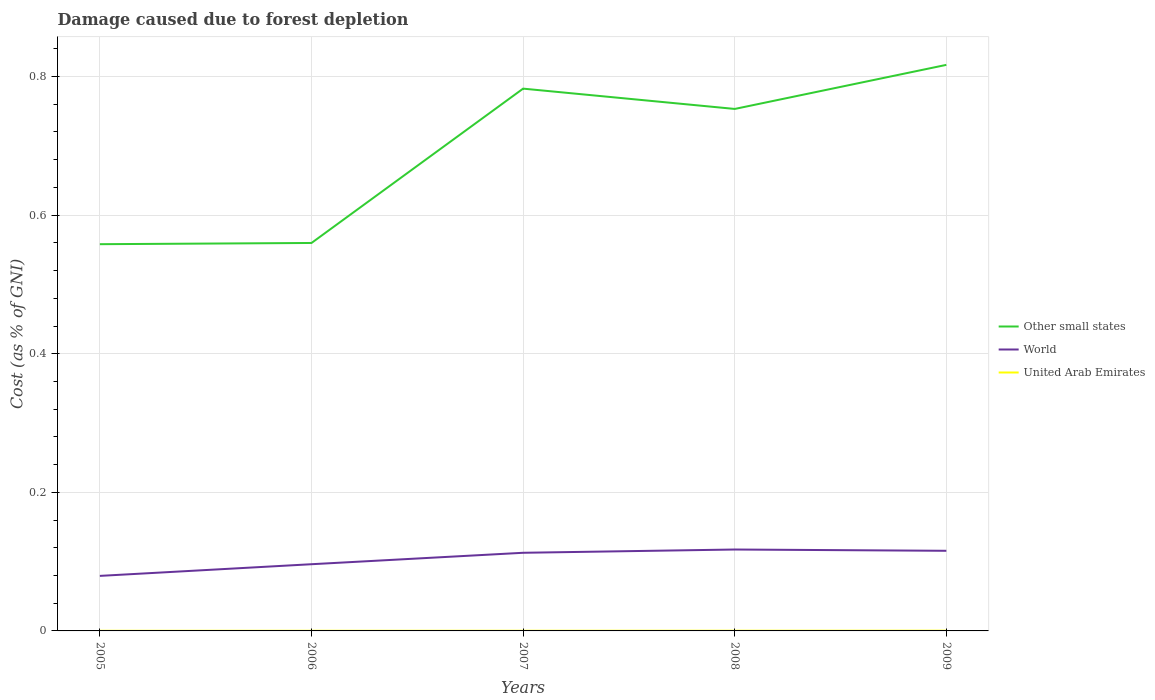How many different coloured lines are there?
Your answer should be compact. 3. Is the number of lines equal to the number of legend labels?
Offer a very short reply. Yes. Across all years, what is the maximum cost of damage caused due to forest depletion in Other small states?
Your answer should be very brief. 0.56. In which year was the cost of damage caused due to forest depletion in World maximum?
Give a very brief answer. 2005. What is the total cost of damage caused due to forest depletion in World in the graph?
Make the answer very short. -0.02. What is the difference between the highest and the second highest cost of damage caused due to forest depletion in World?
Provide a short and direct response. 0.04. What is the difference between the highest and the lowest cost of damage caused due to forest depletion in United Arab Emirates?
Your answer should be very brief. 2. How many years are there in the graph?
Offer a terse response. 5. What is the difference between two consecutive major ticks on the Y-axis?
Make the answer very short. 0.2. Are the values on the major ticks of Y-axis written in scientific E-notation?
Provide a short and direct response. No. Does the graph contain any zero values?
Your response must be concise. No. How are the legend labels stacked?
Ensure brevity in your answer.  Vertical. What is the title of the graph?
Keep it short and to the point. Damage caused due to forest depletion. What is the label or title of the Y-axis?
Provide a succinct answer. Cost (as % of GNI). What is the Cost (as % of GNI) in Other small states in 2005?
Your answer should be compact. 0.56. What is the Cost (as % of GNI) of World in 2005?
Your answer should be compact. 0.08. What is the Cost (as % of GNI) in United Arab Emirates in 2005?
Your answer should be compact. 0. What is the Cost (as % of GNI) in Other small states in 2006?
Your answer should be very brief. 0.56. What is the Cost (as % of GNI) in World in 2006?
Provide a succinct answer. 0.1. What is the Cost (as % of GNI) in United Arab Emirates in 2006?
Make the answer very short. 0. What is the Cost (as % of GNI) in Other small states in 2007?
Your answer should be compact. 0.78. What is the Cost (as % of GNI) in World in 2007?
Provide a short and direct response. 0.11. What is the Cost (as % of GNI) in United Arab Emirates in 2007?
Make the answer very short. 0. What is the Cost (as % of GNI) in Other small states in 2008?
Offer a very short reply. 0.75. What is the Cost (as % of GNI) of World in 2008?
Keep it short and to the point. 0.12. What is the Cost (as % of GNI) in United Arab Emirates in 2008?
Provide a short and direct response. 0. What is the Cost (as % of GNI) in Other small states in 2009?
Your response must be concise. 0.82. What is the Cost (as % of GNI) in World in 2009?
Your answer should be compact. 0.12. What is the Cost (as % of GNI) in United Arab Emirates in 2009?
Make the answer very short. 0. Across all years, what is the maximum Cost (as % of GNI) in Other small states?
Make the answer very short. 0.82. Across all years, what is the maximum Cost (as % of GNI) of World?
Keep it short and to the point. 0.12. Across all years, what is the maximum Cost (as % of GNI) in United Arab Emirates?
Give a very brief answer. 0. Across all years, what is the minimum Cost (as % of GNI) in Other small states?
Your answer should be compact. 0.56. Across all years, what is the minimum Cost (as % of GNI) of World?
Your answer should be very brief. 0.08. Across all years, what is the minimum Cost (as % of GNI) of United Arab Emirates?
Ensure brevity in your answer.  0. What is the total Cost (as % of GNI) of Other small states in the graph?
Ensure brevity in your answer.  3.47. What is the total Cost (as % of GNI) in World in the graph?
Make the answer very short. 0.52. What is the total Cost (as % of GNI) in United Arab Emirates in the graph?
Your answer should be compact. 0. What is the difference between the Cost (as % of GNI) in Other small states in 2005 and that in 2006?
Your response must be concise. -0. What is the difference between the Cost (as % of GNI) of World in 2005 and that in 2006?
Offer a terse response. -0.02. What is the difference between the Cost (as % of GNI) in Other small states in 2005 and that in 2007?
Your response must be concise. -0.22. What is the difference between the Cost (as % of GNI) in World in 2005 and that in 2007?
Offer a terse response. -0.03. What is the difference between the Cost (as % of GNI) in Other small states in 2005 and that in 2008?
Your answer should be compact. -0.2. What is the difference between the Cost (as % of GNI) of World in 2005 and that in 2008?
Make the answer very short. -0.04. What is the difference between the Cost (as % of GNI) in United Arab Emirates in 2005 and that in 2008?
Provide a short and direct response. -0. What is the difference between the Cost (as % of GNI) in Other small states in 2005 and that in 2009?
Your answer should be compact. -0.26. What is the difference between the Cost (as % of GNI) in World in 2005 and that in 2009?
Your response must be concise. -0.04. What is the difference between the Cost (as % of GNI) of United Arab Emirates in 2005 and that in 2009?
Your answer should be compact. -0. What is the difference between the Cost (as % of GNI) in Other small states in 2006 and that in 2007?
Ensure brevity in your answer.  -0.22. What is the difference between the Cost (as % of GNI) in World in 2006 and that in 2007?
Your answer should be very brief. -0.02. What is the difference between the Cost (as % of GNI) of Other small states in 2006 and that in 2008?
Provide a succinct answer. -0.19. What is the difference between the Cost (as % of GNI) in World in 2006 and that in 2008?
Your answer should be compact. -0.02. What is the difference between the Cost (as % of GNI) of United Arab Emirates in 2006 and that in 2008?
Ensure brevity in your answer.  -0. What is the difference between the Cost (as % of GNI) of Other small states in 2006 and that in 2009?
Give a very brief answer. -0.26. What is the difference between the Cost (as % of GNI) in World in 2006 and that in 2009?
Your response must be concise. -0.02. What is the difference between the Cost (as % of GNI) of United Arab Emirates in 2006 and that in 2009?
Your answer should be very brief. -0. What is the difference between the Cost (as % of GNI) of Other small states in 2007 and that in 2008?
Ensure brevity in your answer.  0.03. What is the difference between the Cost (as % of GNI) of World in 2007 and that in 2008?
Offer a very short reply. -0. What is the difference between the Cost (as % of GNI) of United Arab Emirates in 2007 and that in 2008?
Your response must be concise. -0. What is the difference between the Cost (as % of GNI) in Other small states in 2007 and that in 2009?
Offer a terse response. -0.03. What is the difference between the Cost (as % of GNI) in World in 2007 and that in 2009?
Offer a very short reply. -0. What is the difference between the Cost (as % of GNI) in United Arab Emirates in 2007 and that in 2009?
Provide a short and direct response. -0. What is the difference between the Cost (as % of GNI) in Other small states in 2008 and that in 2009?
Offer a very short reply. -0.06. What is the difference between the Cost (as % of GNI) of World in 2008 and that in 2009?
Offer a very short reply. 0. What is the difference between the Cost (as % of GNI) of United Arab Emirates in 2008 and that in 2009?
Provide a short and direct response. -0. What is the difference between the Cost (as % of GNI) in Other small states in 2005 and the Cost (as % of GNI) in World in 2006?
Make the answer very short. 0.46. What is the difference between the Cost (as % of GNI) of Other small states in 2005 and the Cost (as % of GNI) of United Arab Emirates in 2006?
Provide a short and direct response. 0.56. What is the difference between the Cost (as % of GNI) in World in 2005 and the Cost (as % of GNI) in United Arab Emirates in 2006?
Make the answer very short. 0.08. What is the difference between the Cost (as % of GNI) in Other small states in 2005 and the Cost (as % of GNI) in World in 2007?
Provide a short and direct response. 0.45. What is the difference between the Cost (as % of GNI) in Other small states in 2005 and the Cost (as % of GNI) in United Arab Emirates in 2007?
Keep it short and to the point. 0.56. What is the difference between the Cost (as % of GNI) of World in 2005 and the Cost (as % of GNI) of United Arab Emirates in 2007?
Offer a very short reply. 0.08. What is the difference between the Cost (as % of GNI) in Other small states in 2005 and the Cost (as % of GNI) in World in 2008?
Ensure brevity in your answer.  0.44. What is the difference between the Cost (as % of GNI) in Other small states in 2005 and the Cost (as % of GNI) in United Arab Emirates in 2008?
Offer a very short reply. 0.56. What is the difference between the Cost (as % of GNI) of World in 2005 and the Cost (as % of GNI) of United Arab Emirates in 2008?
Your answer should be very brief. 0.08. What is the difference between the Cost (as % of GNI) in Other small states in 2005 and the Cost (as % of GNI) in World in 2009?
Offer a very short reply. 0.44. What is the difference between the Cost (as % of GNI) of Other small states in 2005 and the Cost (as % of GNI) of United Arab Emirates in 2009?
Offer a terse response. 0.56. What is the difference between the Cost (as % of GNI) in World in 2005 and the Cost (as % of GNI) in United Arab Emirates in 2009?
Offer a very short reply. 0.08. What is the difference between the Cost (as % of GNI) in Other small states in 2006 and the Cost (as % of GNI) in World in 2007?
Your answer should be compact. 0.45. What is the difference between the Cost (as % of GNI) in Other small states in 2006 and the Cost (as % of GNI) in United Arab Emirates in 2007?
Your answer should be very brief. 0.56. What is the difference between the Cost (as % of GNI) of World in 2006 and the Cost (as % of GNI) of United Arab Emirates in 2007?
Offer a terse response. 0.1. What is the difference between the Cost (as % of GNI) of Other small states in 2006 and the Cost (as % of GNI) of World in 2008?
Ensure brevity in your answer.  0.44. What is the difference between the Cost (as % of GNI) of Other small states in 2006 and the Cost (as % of GNI) of United Arab Emirates in 2008?
Your answer should be compact. 0.56. What is the difference between the Cost (as % of GNI) in World in 2006 and the Cost (as % of GNI) in United Arab Emirates in 2008?
Offer a terse response. 0.1. What is the difference between the Cost (as % of GNI) of Other small states in 2006 and the Cost (as % of GNI) of World in 2009?
Give a very brief answer. 0.44. What is the difference between the Cost (as % of GNI) in Other small states in 2006 and the Cost (as % of GNI) in United Arab Emirates in 2009?
Ensure brevity in your answer.  0.56. What is the difference between the Cost (as % of GNI) of World in 2006 and the Cost (as % of GNI) of United Arab Emirates in 2009?
Keep it short and to the point. 0.1. What is the difference between the Cost (as % of GNI) of Other small states in 2007 and the Cost (as % of GNI) of World in 2008?
Ensure brevity in your answer.  0.67. What is the difference between the Cost (as % of GNI) in Other small states in 2007 and the Cost (as % of GNI) in United Arab Emirates in 2008?
Make the answer very short. 0.78. What is the difference between the Cost (as % of GNI) of World in 2007 and the Cost (as % of GNI) of United Arab Emirates in 2008?
Your answer should be very brief. 0.11. What is the difference between the Cost (as % of GNI) in Other small states in 2007 and the Cost (as % of GNI) in World in 2009?
Offer a very short reply. 0.67. What is the difference between the Cost (as % of GNI) of Other small states in 2007 and the Cost (as % of GNI) of United Arab Emirates in 2009?
Offer a very short reply. 0.78. What is the difference between the Cost (as % of GNI) of World in 2007 and the Cost (as % of GNI) of United Arab Emirates in 2009?
Give a very brief answer. 0.11. What is the difference between the Cost (as % of GNI) in Other small states in 2008 and the Cost (as % of GNI) in World in 2009?
Give a very brief answer. 0.64. What is the difference between the Cost (as % of GNI) of Other small states in 2008 and the Cost (as % of GNI) of United Arab Emirates in 2009?
Provide a short and direct response. 0.75. What is the difference between the Cost (as % of GNI) in World in 2008 and the Cost (as % of GNI) in United Arab Emirates in 2009?
Your answer should be compact. 0.12. What is the average Cost (as % of GNI) in Other small states per year?
Your answer should be very brief. 0.69. What is the average Cost (as % of GNI) of World per year?
Your response must be concise. 0.1. In the year 2005, what is the difference between the Cost (as % of GNI) in Other small states and Cost (as % of GNI) in World?
Give a very brief answer. 0.48. In the year 2005, what is the difference between the Cost (as % of GNI) of Other small states and Cost (as % of GNI) of United Arab Emirates?
Provide a short and direct response. 0.56. In the year 2005, what is the difference between the Cost (as % of GNI) in World and Cost (as % of GNI) in United Arab Emirates?
Give a very brief answer. 0.08. In the year 2006, what is the difference between the Cost (as % of GNI) of Other small states and Cost (as % of GNI) of World?
Offer a terse response. 0.46. In the year 2006, what is the difference between the Cost (as % of GNI) of Other small states and Cost (as % of GNI) of United Arab Emirates?
Ensure brevity in your answer.  0.56. In the year 2006, what is the difference between the Cost (as % of GNI) in World and Cost (as % of GNI) in United Arab Emirates?
Offer a terse response. 0.1. In the year 2007, what is the difference between the Cost (as % of GNI) in Other small states and Cost (as % of GNI) in World?
Your answer should be very brief. 0.67. In the year 2007, what is the difference between the Cost (as % of GNI) in Other small states and Cost (as % of GNI) in United Arab Emirates?
Give a very brief answer. 0.78. In the year 2007, what is the difference between the Cost (as % of GNI) of World and Cost (as % of GNI) of United Arab Emirates?
Your answer should be very brief. 0.11. In the year 2008, what is the difference between the Cost (as % of GNI) of Other small states and Cost (as % of GNI) of World?
Make the answer very short. 0.64. In the year 2008, what is the difference between the Cost (as % of GNI) in Other small states and Cost (as % of GNI) in United Arab Emirates?
Your answer should be very brief. 0.75. In the year 2008, what is the difference between the Cost (as % of GNI) in World and Cost (as % of GNI) in United Arab Emirates?
Ensure brevity in your answer.  0.12. In the year 2009, what is the difference between the Cost (as % of GNI) of Other small states and Cost (as % of GNI) of World?
Your response must be concise. 0.7. In the year 2009, what is the difference between the Cost (as % of GNI) of Other small states and Cost (as % of GNI) of United Arab Emirates?
Offer a terse response. 0.82. In the year 2009, what is the difference between the Cost (as % of GNI) of World and Cost (as % of GNI) of United Arab Emirates?
Offer a terse response. 0.12. What is the ratio of the Cost (as % of GNI) in World in 2005 to that in 2006?
Offer a terse response. 0.83. What is the ratio of the Cost (as % of GNI) in United Arab Emirates in 2005 to that in 2006?
Your response must be concise. 0.96. What is the ratio of the Cost (as % of GNI) in Other small states in 2005 to that in 2007?
Offer a terse response. 0.71. What is the ratio of the Cost (as % of GNI) in World in 2005 to that in 2007?
Your answer should be compact. 0.7. What is the ratio of the Cost (as % of GNI) of United Arab Emirates in 2005 to that in 2007?
Your answer should be compact. 0.81. What is the ratio of the Cost (as % of GNI) in Other small states in 2005 to that in 2008?
Ensure brevity in your answer.  0.74. What is the ratio of the Cost (as % of GNI) in World in 2005 to that in 2008?
Make the answer very short. 0.68. What is the ratio of the Cost (as % of GNI) in United Arab Emirates in 2005 to that in 2008?
Your answer should be very brief. 0.7. What is the ratio of the Cost (as % of GNI) in Other small states in 2005 to that in 2009?
Keep it short and to the point. 0.68. What is the ratio of the Cost (as % of GNI) of World in 2005 to that in 2009?
Your answer should be compact. 0.69. What is the ratio of the Cost (as % of GNI) of United Arab Emirates in 2005 to that in 2009?
Provide a short and direct response. 0.59. What is the ratio of the Cost (as % of GNI) of Other small states in 2006 to that in 2007?
Your answer should be very brief. 0.72. What is the ratio of the Cost (as % of GNI) of World in 2006 to that in 2007?
Keep it short and to the point. 0.85. What is the ratio of the Cost (as % of GNI) in United Arab Emirates in 2006 to that in 2007?
Provide a succinct answer. 0.84. What is the ratio of the Cost (as % of GNI) in Other small states in 2006 to that in 2008?
Provide a succinct answer. 0.74. What is the ratio of the Cost (as % of GNI) of World in 2006 to that in 2008?
Keep it short and to the point. 0.82. What is the ratio of the Cost (as % of GNI) of United Arab Emirates in 2006 to that in 2008?
Your answer should be very brief. 0.73. What is the ratio of the Cost (as % of GNI) of Other small states in 2006 to that in 2009?
Your response must be concise. 0.69. What is the ratio of the Cost (as % of GNI) in World in 2006 to that in 2009?
Keep it short and to the point. 0.83. What is the ratio of the Cost (as % of GNI) in United Arab Emirates in 2006 to that in 2009?
Your response must be concise. 0.62. What is the ratio of the Cost (as % of GNI) of Other small states in 2007 to that in 2008?
Ensure brevity in your answer.  1.04. What is the ratio of the Cost (as % of GNI) in United Arab Emirates in 2007 to that in 2008?
Your answer should be very brief. 0.87. What is the ratio of the Cost (as % of GNI) in Other small states in 2007 to that in 2009?
Offer a terse response. 0.96. What is the ratio of the Cost (as % of GNI) in World in 2007 to that in 2009?
Ensure brevity in your answer.  0.98. What is the ratio of the Cost (as % of GNI) in United Arab Emirates in 2007 to that in 2009?
Offer a very short reply. 0.74. What is the ratio of the Cost (as % of GNI) in Other small states in 2008 to that in 2009?
Your answer should be compact. 0.92. What is the ratio of the Cost (as % of GNI) in United Arab Emirates in 2008 to that in 2009?
Give a very brief answer. 0.85. What is the difference between the highest and the second highest Cost (as % of GNI) of Other small states?
Provide a succinct answer. 0.03. What is the difference between the highest and the second highest Cost (as % of GNI) in World?
Keep it short and to the point. 0. What is the difference between the highest and the lowest Cost (as % of GNI) in Other small states?
Make the answer very short. 0.26. What is the difference between the highest and the lowest Cost (as % of GNI) of World?
Offer a very short reply. 0.04. 